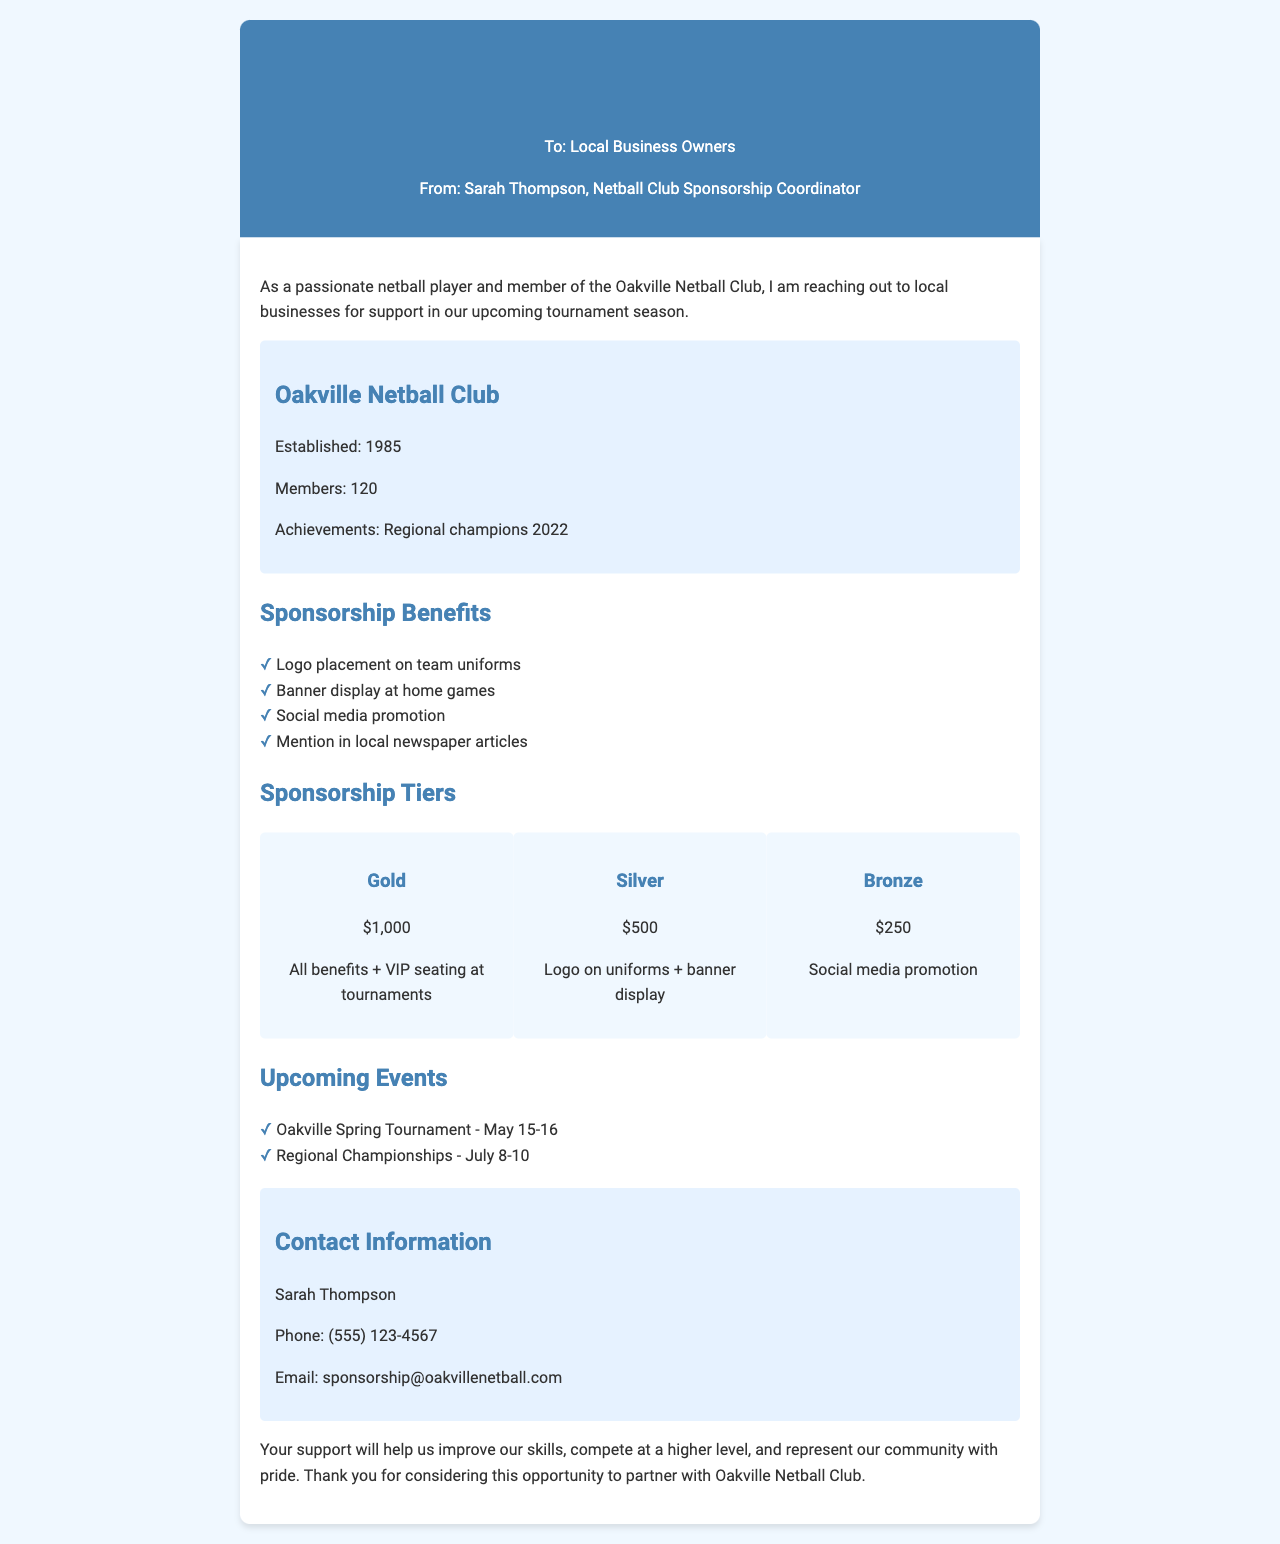What is the name of the club? The document mentions the club by name, which is the Oakville Netball Club.
Answer: Oakville Netball Club Who is the sponsorship coordinator? The document states that Sarah Thompson is the sponsorship coordinator.
Answer: Sarah Thompson What are the three sponsorship tiers? The document lists the three tiers: Gold, Silver, and Bronze.
Answer: Gold, Silver, Bronze What is the cost of the Gold sponsorship? The cost is specified in the document for the Gold tier sponsorship.
Answer: $1,000 When is the Oakville Spring Tournament scheduled? The document provides a date for the Oakville Spring Tournament as May 15-16.
Answer: May 15-16 What benefit is offered at the Silver tier? The document outlines benefits for the Silver tier, including logo on uniforms and banner display.
Answer: Logo on uniforms + banner display What major achievement did the club have in 2022? The club's achievement mentioned in the document is being regional champions.
Answer: Regional champions 2022 What type of promotion is included for the Bronze tier? The document states the Bronze tier includes social media promotion.
Answer: Social media promotion What is the email address for sponsorship inquiries? The document provides the email address for contacting about sponsorships, which is listed.
Answer: sponsorship@oakvillenetball.com 